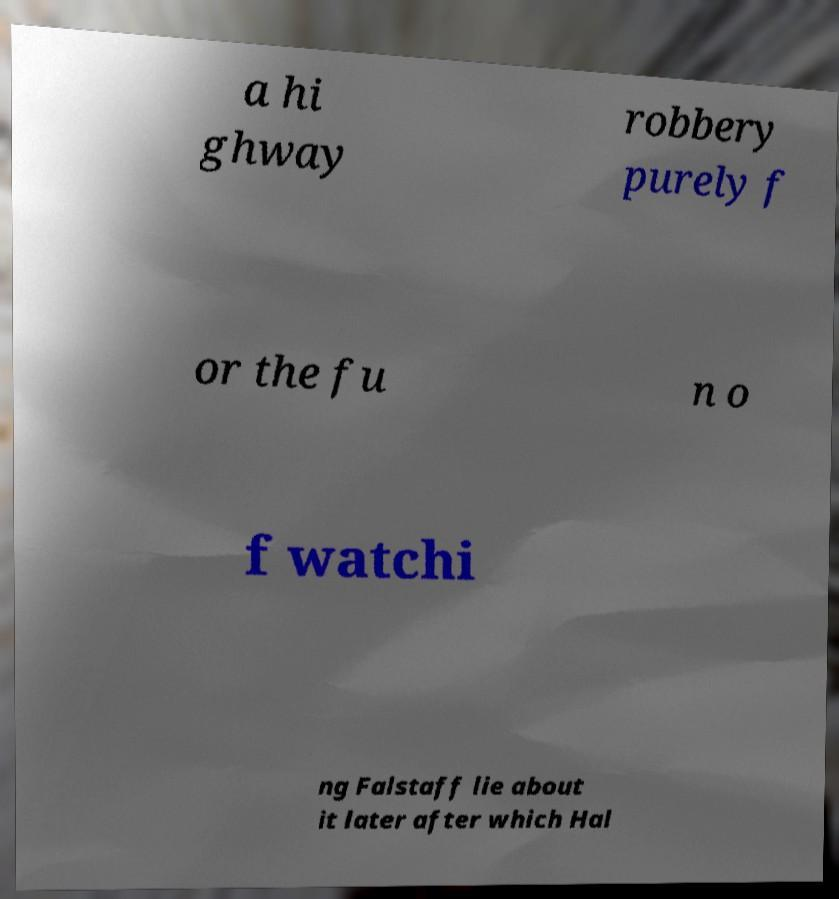For documentation purposes, I need the text within this image transcribed. Could you provide that? a hi ghway robbery purely f or the fu n o f watchi ng Falstaff lie about it later after which Hal 